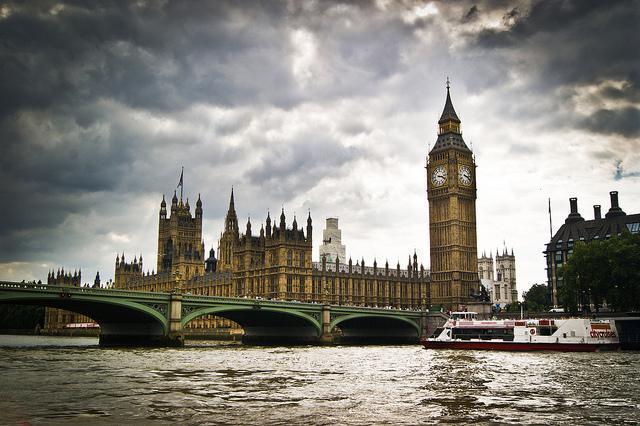How many donuts are in the box?
Give a very brief answer. 0. 